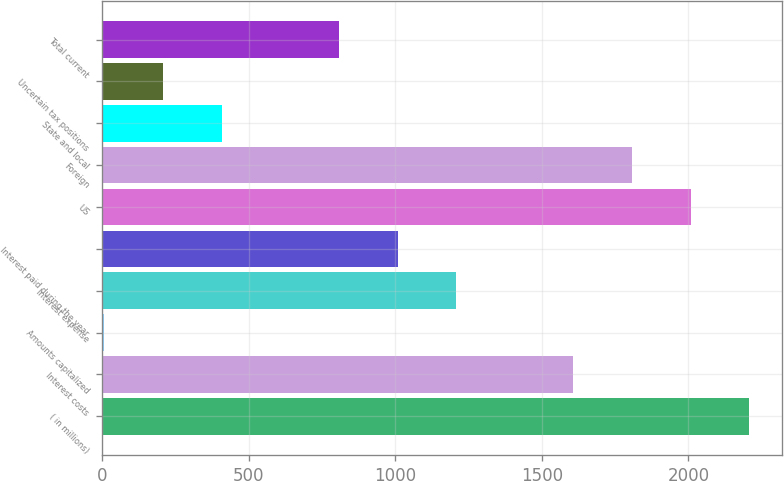<chart> <loc_0><loc_0><loc_500><loc_500><bar_chart><fcel>( in millions)<fcel>Interest costs<fcel>Amounts capitalized<fcel>Interest expense<fcel>Interest paid during the year<fcel>US<fcel>Foreign<fcel>State and local<fcel>Uncertain tax positions<fcel>Total current<nl><fcel>2208.08<fcel>1607.84<fcel>7.2<fcel>1207.68<fcel>1007.6<fcel>2008<fcel>1807.92<fcel>407.36<fcel>207.28<fcel>807.52<nl></chart> 